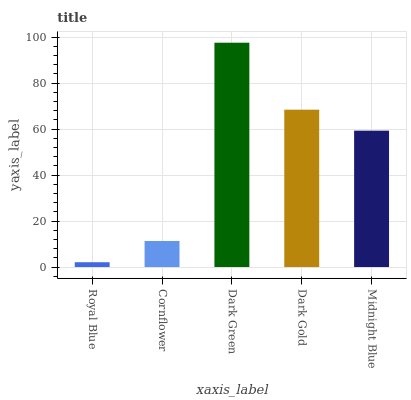Is Royal Blue the minimum?
Answer yes or no. Yes. Is Dark Green the maximum?
Answer yes or no. Yes. Is Cornflower the minimum?
Answer yes or no. No. Is Cornflower the maximum?
Answer yes or no. No. Is Cornflower greater than Royal Blue?
Answer yes or no. Yes. Is Royal Blue less than Cornflower?
Answer yes or no. Yes. Is Royal Blue greater than Cornflower?
Answer yes or no. No. Is Cornflower less than Royal Blue?
Answer yes or no. No. Is Midnight Blue the high median?
Answer yes or no. Yes. Is Midnight Blue the low median?
Answer yes or no. Yes. Is Royal Blue the high median?
Answer yes or no. No. Is Dark Green the low median?
Answer yes or no. No. 